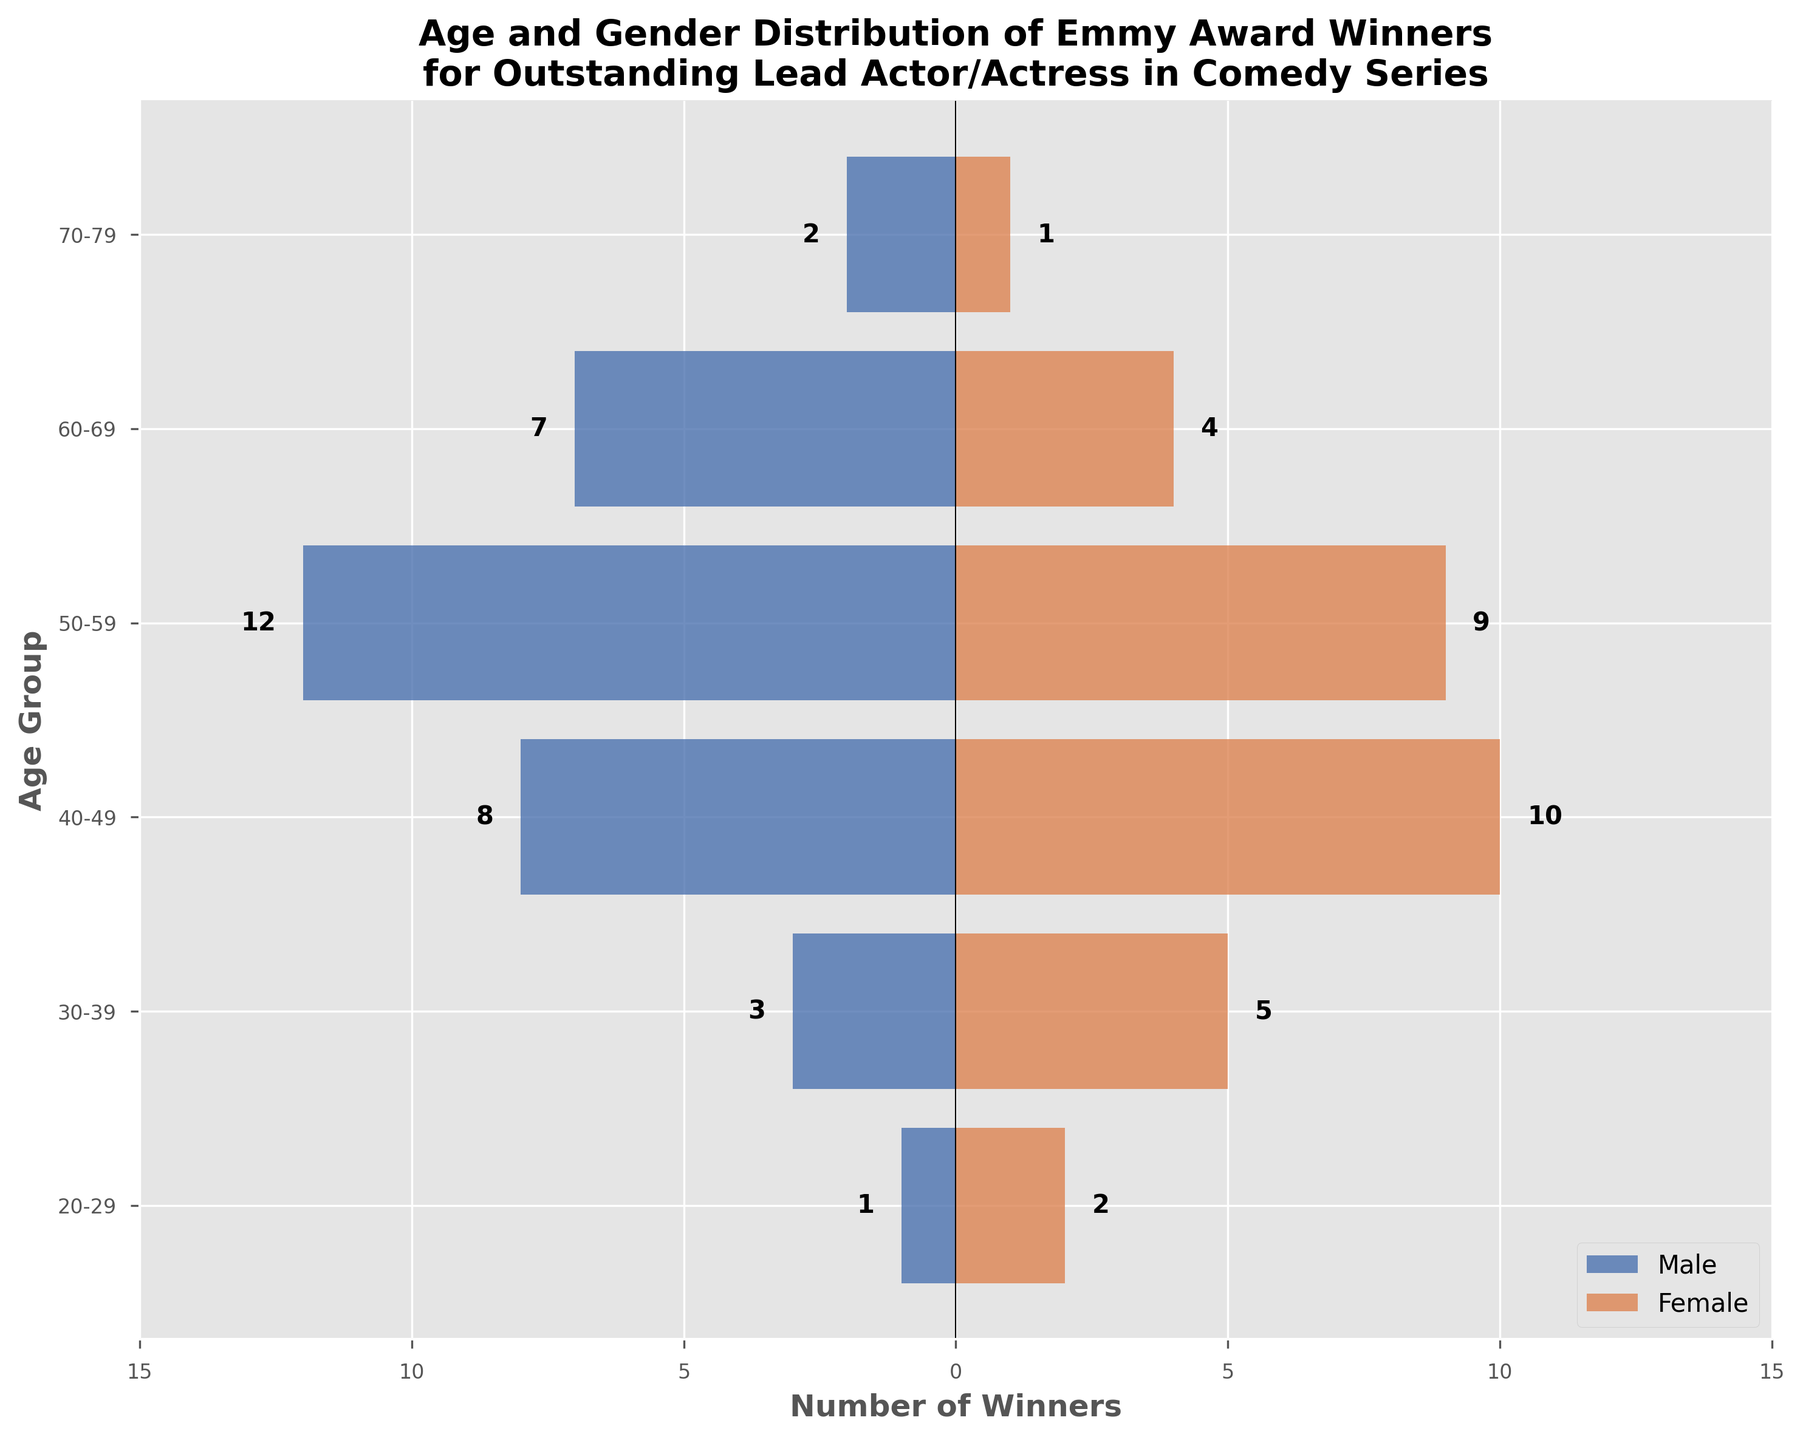what age group has the highest number of male Emmy winners? The age group with the longest bar on the male side indicates the highest number of male Emmy winners. The longest bar on the male side corresponds to the 50-59 age group.
Answer: 50-59 how many total Emmy winners are in the 60-69 age group? To find the total winners in the 60-69 age group, add the number of male winners to the number of female winners: 7 (male) + 4 (female).
Answer: 11 which gender has more winners in the 40-49 age group? Compare the length of the bars for males and females in the 40-49 age group. The female bar is longer with 10 winners, compared to the male bar with 8 winners.
Answer: Female what is the least represented age group for females? Look for the shortest bar on the female side. The 70-79 age group has the shortest bar with only 1 winner.
Answer: 70-79 how many more male winners are there than female winners in the 50-59 age group? Subtract the number of female winners from the number of male winners: 12 (male) - 9 (female).
Answer: 3 what is the total number of Emmy winners aged 30-49? Add the number of male and female winners for the 30-39 and 40-49 age groups: (3 + 5) + (8 + 10).
Answer: 26 are there any age groups where males and females have the same number of winners? Compare the bars for each age group to see if any have equal lengths. There is no age group where the number of male and female winners is the same.
Answer: No which age group has the smallest total number of winners? Sum the male and female winners for each age group and find the smallest total. The 70-79 age group has the smallest total with only 3 winners (2 male + 1 female).
Answer: 70-79 